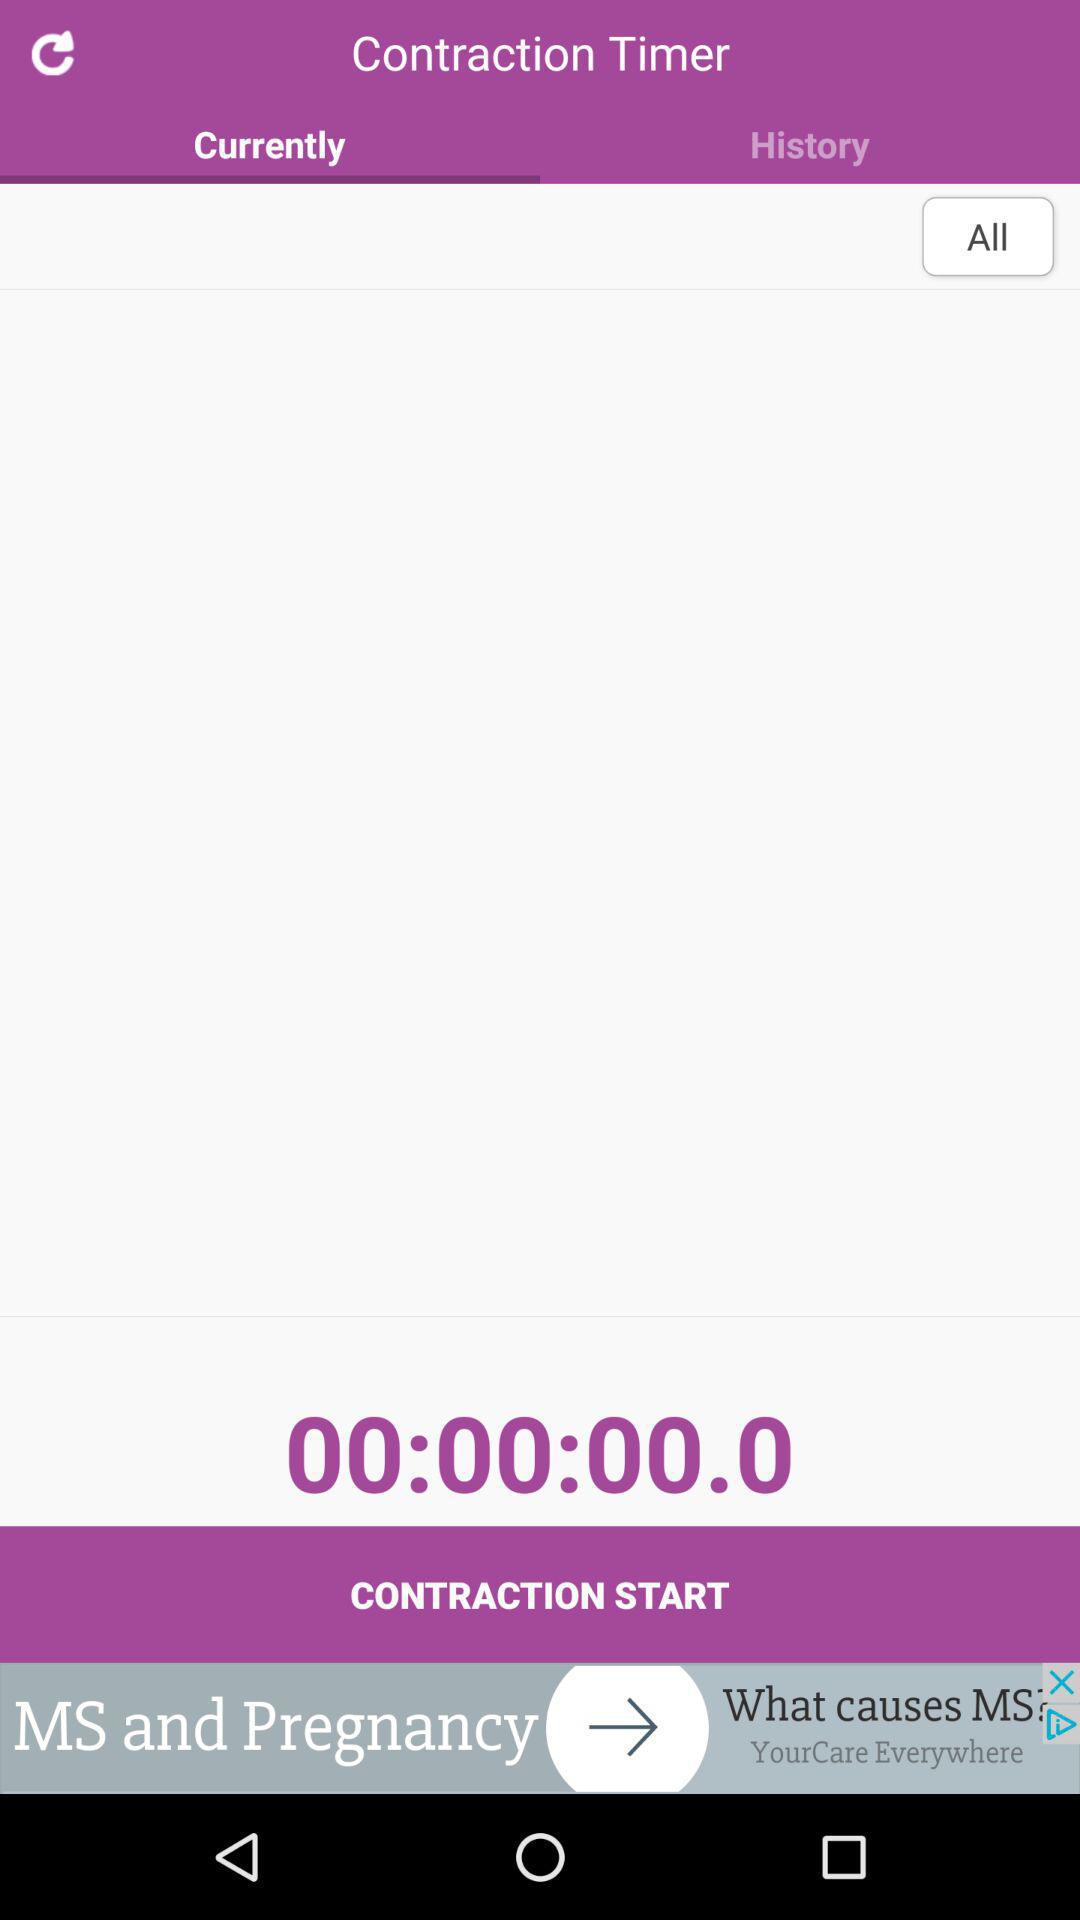What is the current contraction time? The current contraction time is 00:00:00.0. 